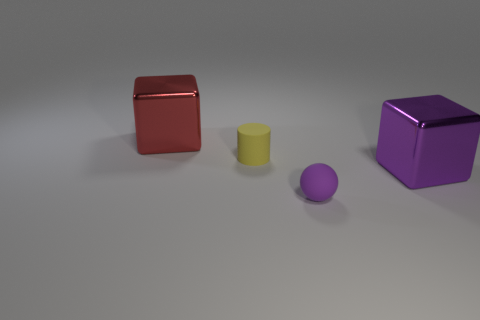Are the small sphere and the large thing that is on the right side of the tiny sphere made of the same material?
Provide a succinct answer. No. What number of things are either large cubes behind the tiny yellow rubber object or big things behind the large purple block?
Your response must be concise. 1. The tiny ball is what color?
Ensure brevity in your answer.  Purple. Is the number of yellow matte cylinders that are on the left side of the sphere less than the number of big things?
Keep it short and to the point. Yes. Are there any other things that are the same shape as the small purple matte thing?
Offer a very short reply. No. Is there a tiny yellow rubber sphere?
Provide a succinct answer. No. Are there fewer rubber spheres than large metal things?
Keep it short and to the point. Yes. How many big purple objects have the same material as the big red block?
Keep it short and to the point. 1. There is a big cube that is the same material as the red thing; what color is it?
Offer a very short reply. Purple. There is a big purple metallic object; what shape is it?
Your response must be concise. Cube. 